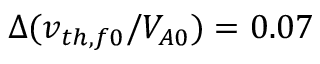<formula> <loc_0><loc_0><loc_500><loc_500>\Delta ( v _ { t h , f 0 } / V _ { A 0 } ) = 0 . 0 7</formula> 